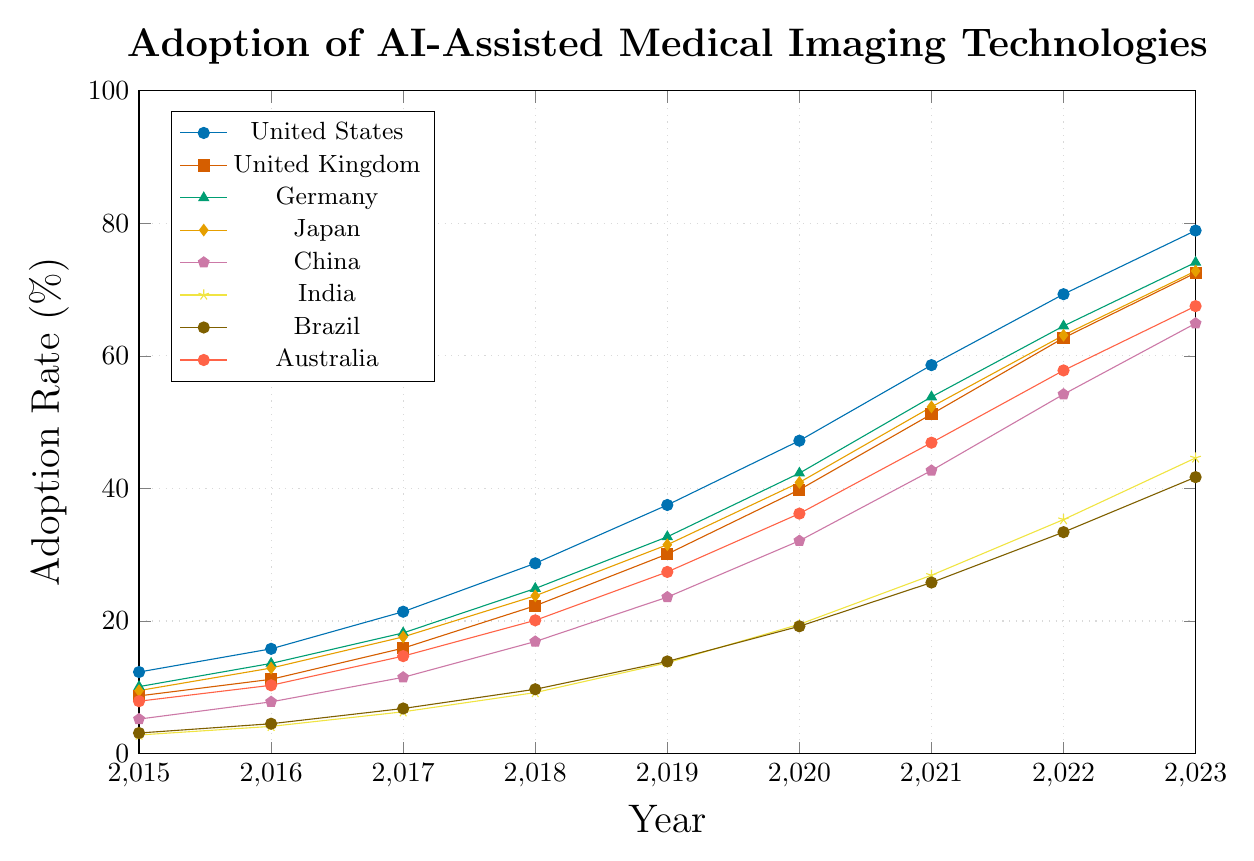Which country had the highest adoption rate in 2023? Look at the adoption rates for 2023 across all countries. The United States has the highest rate at 78.9%.
Answer: United States Which country had the lowest adoption rate in 2015? Compare the adoption rates for 2015 across all countries. India has the lowest adoption rate at 2.8%.
Answer: India Between 2017 and 2020, which country saw the largest increase in adoption rate? Calculate the increase for each country between 2017 and 2020 by subtracting the 2017 rate from the 2020 rate. Compare the increases: United States (47.2 - 21.4 = 25.8), United Kingdom (39.8 - 15.9 = 23.9), Germany (42.3 - 18.2 = 24.1), Japan (40.9 - 17.6 = 23.3), China (32.1 - 11.5 = 20.6), India (19.5 - 6.3 = 13.2), Brazil (19.2 - 6.8 = 12.4), Australia (36.2 - 14.7 = 21.5). The United States saw the largest increase of 25.8%.
Answer: United States In 2019, which country had a higher adoption rate: Japan or Germany? Compare the adoption rates for Japan and Germany in 2019: Japan (31.5) and Germany (32.7). Germany had a higher rate.
Answer: Germany What’s the average adoption rate of AI-assisted medical imaging technologies in Australia from 2015 to 2023? Sum the rates for Australia from 2015 to 2023 and divide by the number of years. (7.9 + 10.3 + 14.7 + 20.1 + 27.4 + 36.2 + 46.9 + 57.8 + 67.5) / 9 = 32.1.
Answer: 32.1 How much did the adoption rate in China increase from 2018 to 2023? Subtract the 2018 rate for China from the 2023 rate: 64.9 - 16.9 = 48.0.
Answer: 48.0 Which country had the fastest-growing adoption rate between 2021 and 2022? Calculate the increase for each country between 2021 and 2022 and compare them: United States (69.3 - 58.6 = 10.7), United Kingdom (62.7 - 51.2 = 11.5), Germany (64.5 - 53.8 = 10.7), Japan (63.1 - 52.3 = 10.8), China (54.2 - 42.7 = 11.5), India (35.3 - 26.9 = 8.4), Brazil (33.4 - 25.8 = 7.6), Australia (57.8 - 46.9 = 10.9). The United Kingdom and China both had the fastest-growing rate of 11.5.
Answer: United Kingdom or China In 2020, did the adoption rate of AI-assisted medical imaging technologies in Brazil surpass 20%? Look at the adoption rate for Brazil in 2020 which is 19.2%. It did not surpass 20%.
Answer: No 